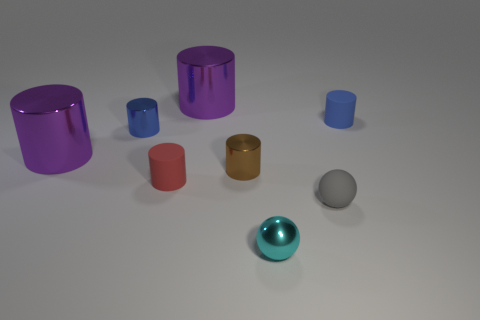Subtract all red balls. Subtract all green cubes. How many balls are left? 2 Subtract all gray spheres. How many cyan cylinders are left? 0 Add 6 small cyans. How many blues exist? 0 Subtract all tiny cyan shiny balls. Subtract all small red rubber objects. How many objects are left? 6 Add 3 tiny cylinders. How many tiny cylinders are left? 7 Add 6 tiny red cylinders. How many tiny red cylinders exist? 7 Add 2 gray balls. How many objects exist? 10 Subtract all purple cylinders. How many cylinders are left? 4 Subtract all red cylinders. How many cylinders are left? 5 Subtract 1 cyan spheres. How many objects are left? 7 